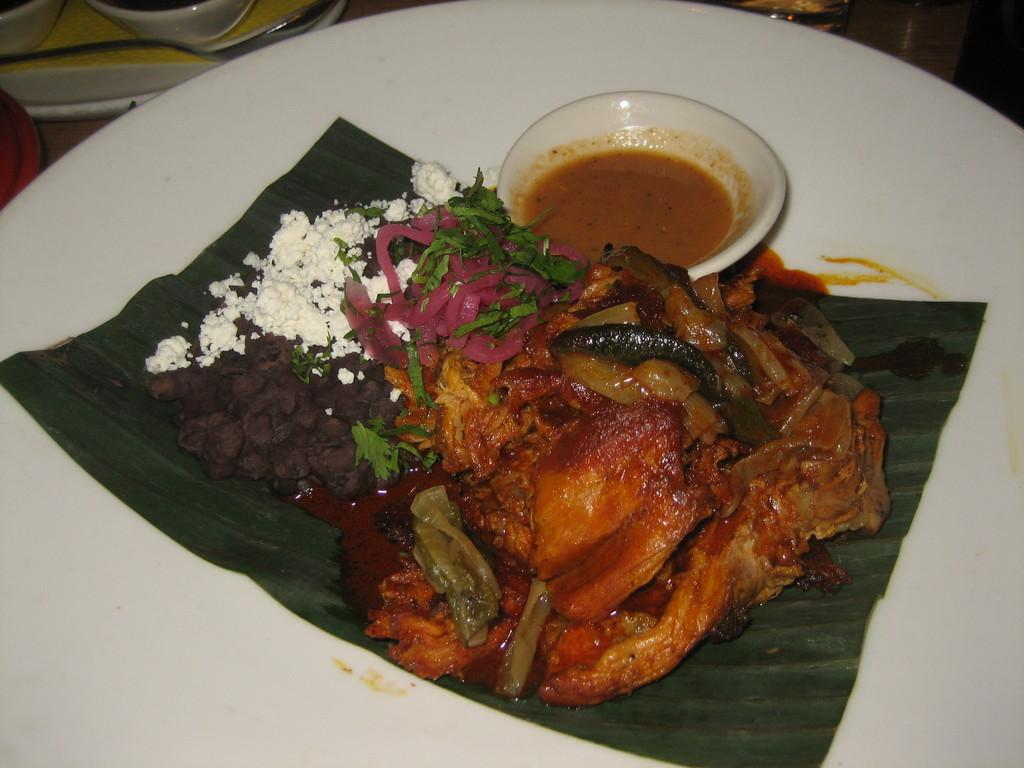What is present on the plate in the image? There are food items on the plate in the image. What else can be seen in the image besides the plate? There is a bowl in the image. What is located near the plate and bowl in the image? There are objects at the side of the plate and bowl in the image. What verse is being recited by the birthday bun in the image? There is no birthday bun or verse present in the image. 